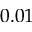<formula> <loc_0><loc_0><loc_500><loc_500>0 . 0 1</formula> 